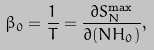<formula> <loc_0><loc_0><loc_500><loc_500>\beta _ { 0 } = \frac { 1 } { T } = \frac { \partial S ^ { \max } _ { N } } { \partial ( N H _ { 0 } ) } ,</formula> 